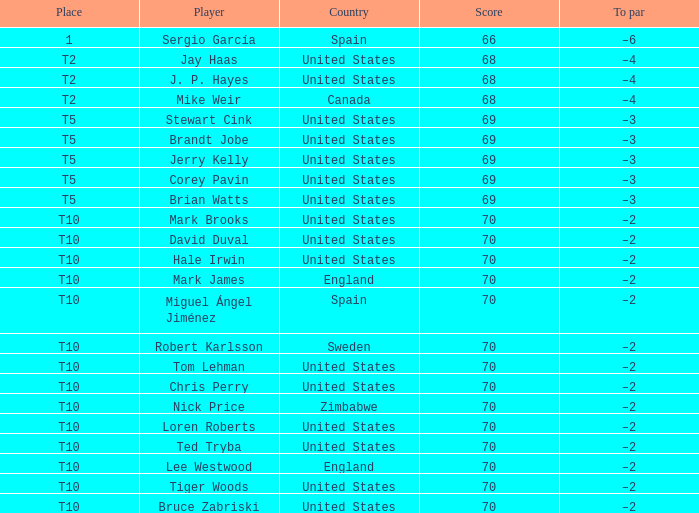What was the highest score of t5 place finisher brandt jobe? 69.0. 